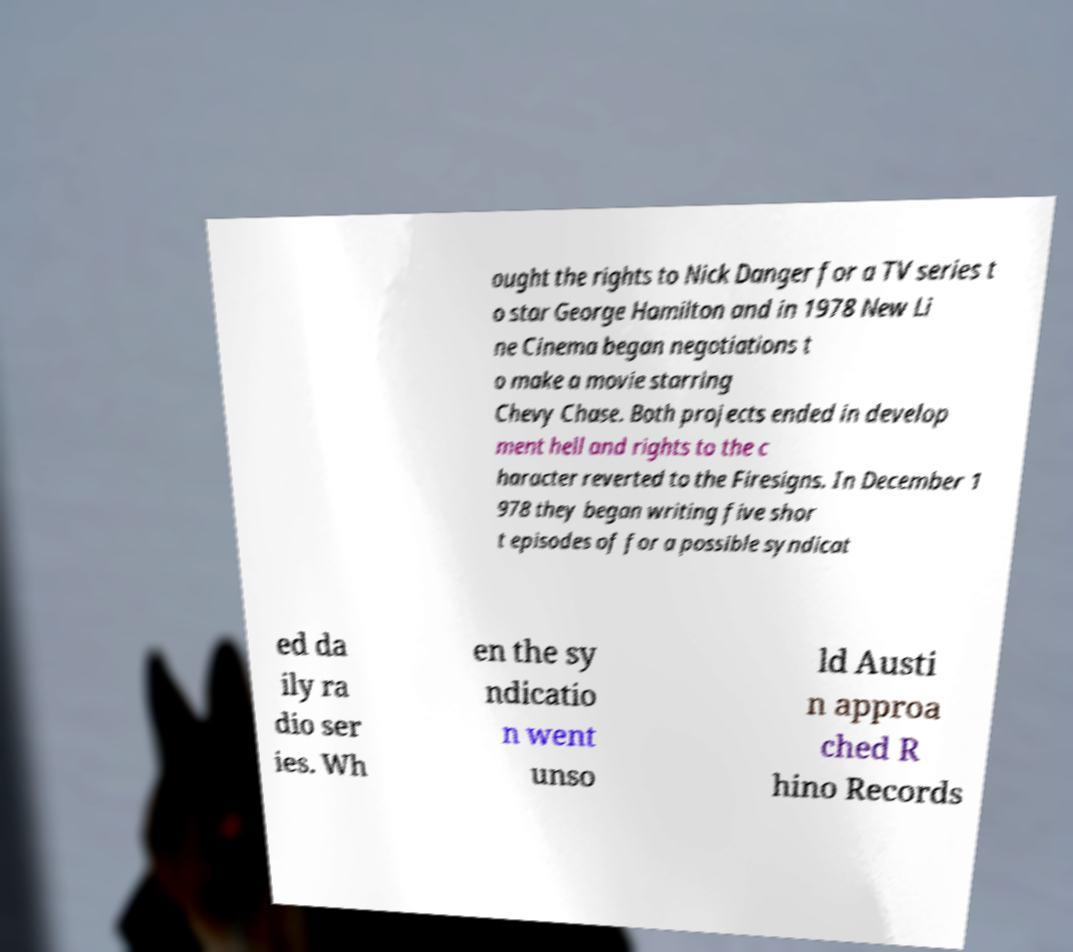For documentation purposes, I need the text within this image transcribed. Could you provide that? ought the rights to Nick Danger for a TV series t o star George Hamilton and in 1978 New Li ne Cinema began negotiations t o make a movie starring Chevy Chase. Both projects ended in develop ment hell and rights to the c haracter reverted to the Firesigns. In December 1 978 they began writing five shor t episodes of for a possible syndicat ed da ily ra dio ser ies. Wh en the sy ndicatio n went unso ld Austi n approa ched R hino Records 